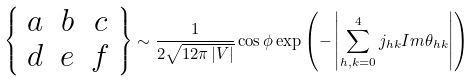Convert formula to latex. <formula><loc_0><loc_0><loc_500><loc_500>\left \{ \begin{array} { c c c } a & b & c \\ d & e & f \end{array} \right \} \sim \frac { 1 } { 2 \sqrt { 1 2 \pi \left | V \right | } } \cos \phi \exp \left ( - \left | \sum ^ { 4 } _ { h , k = 0 } j _ { h k } I m \theta _ { h k } \right | \right )</formula> 